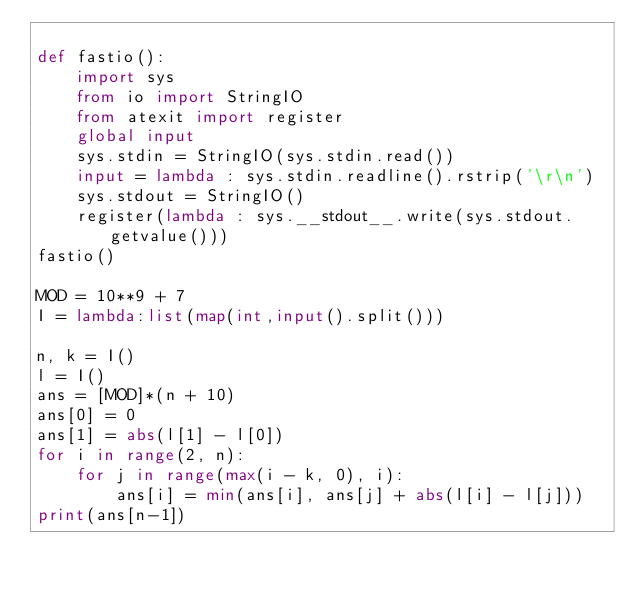Convert code to text. <code><loc_0><loc_0><loc_500><loc_500><_Python_>
def fastio():
    import sys
    from io import StringIO 
    from atexit import register
    global input
    sys.stdin = StringIO(sys.stdin.read())
    input = lambda : sys.stdin.readline().rstrip('\r\n')
    sys.stdout = StringIO()
    register(lambda : sys.__stdout__.write(sys.stdout.getvalue()))
fastio()

MOD = 10**9 + 7
I = lambda:list(map(int,input().split()))

n, k = I()
l = I()
ans = [MOD]*(n + 10)
ans[0] = 0
ans[1] = abs(l[1] - l[0])
for i in range(2, n):
    for j in range(max(i - k, 0), i):
        ans[i] = min(ans[i], ans[j] + abs(l[i] - l[j]))
print(ans[n-1])</code> 